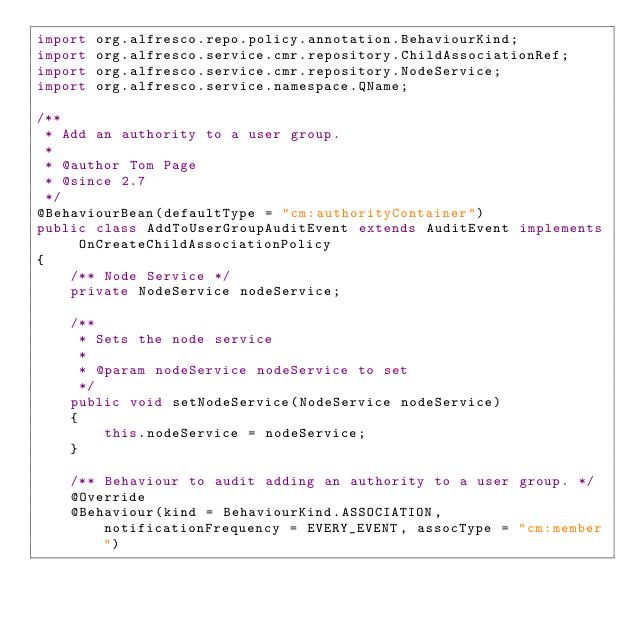<code> <loc_0><loc_0><loc_500><loc_500><_Java_>import org.alfresco.repo.policy.annotation.BehaviourKind;
import org.alfresco.service.cmr.repository.ChildAssociationRef;
import org.alfresco.service.cmr.repository.NodeService;
import org.alfresco.service.namespace.QName;

/**
 * Add an authority to a user group.
 *
 * @author Tom Page
 * @since 2.7
 */
@BehaviourBean(defaultType = "cm:authorityContainer")
public class AddToUserGroupAuditEvent extends AuditEvent implements OnCreateChildAssociationPolicy
{
    /** Node Service */
    private NodeService nodeService;

    /**
     * Sets the node service
     *
     * @param nodeService nodeService to set
     */
    public void setNodeService(NodeService nodeService)
    {
        this.nodeService = nodeService;
    }

    /** Behaviour to audit adding an authority to a user group. */
    @Override
    @Behaviour(kind = BehaviourKind.ASSOCIATION, notificationFrequency = EVERY_EVENT, assocType = "cm:member")</code> 